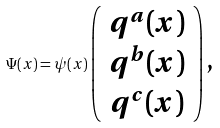Convert formula to latex. <formula><loc_0><loc_0><loc_500><loc_500>\Psi ( x ) = { \psi } ( x ) \left ( \begin{array} { c } q ^ { a } ( x ) \\ q ^ { b } ( x ) \\ q ^ { c } ( x ) \end{array} \right ) \text {,}</formula> 